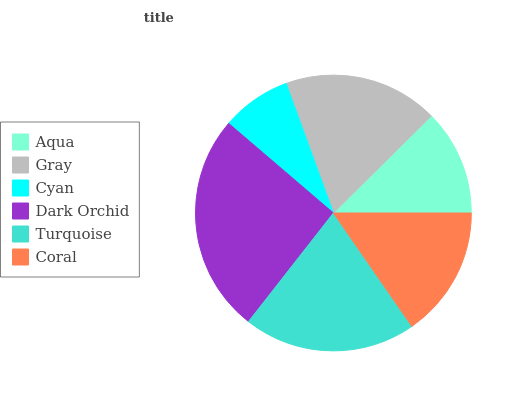Is Cyan the minimum?
Answer yes or no. Yes. Is Dark Orchid the maximum?
Answer yes or no. Yes. Is Gray the minimum?
Answer yes or no. No. Is Gray the maximum?
Answer yes or no. No. Is Gray greater than Aqua?
Answer yes or no. Yes. Is Aqua less than Gray?
Answer yes or no. Yes. Is Aqua greater than Gray?
Answer yes or no. No. Is Gray less than Aqua?
Answer yes or no. No. Is Gray the high median?
Answer yes or no. Yes. Is Coral the low median?
Answer yes or no. Yes. Is Dark Orchid the high median?
Answer yes or no. No. Is Turquoise the low median?
Answer yes or no. No. 